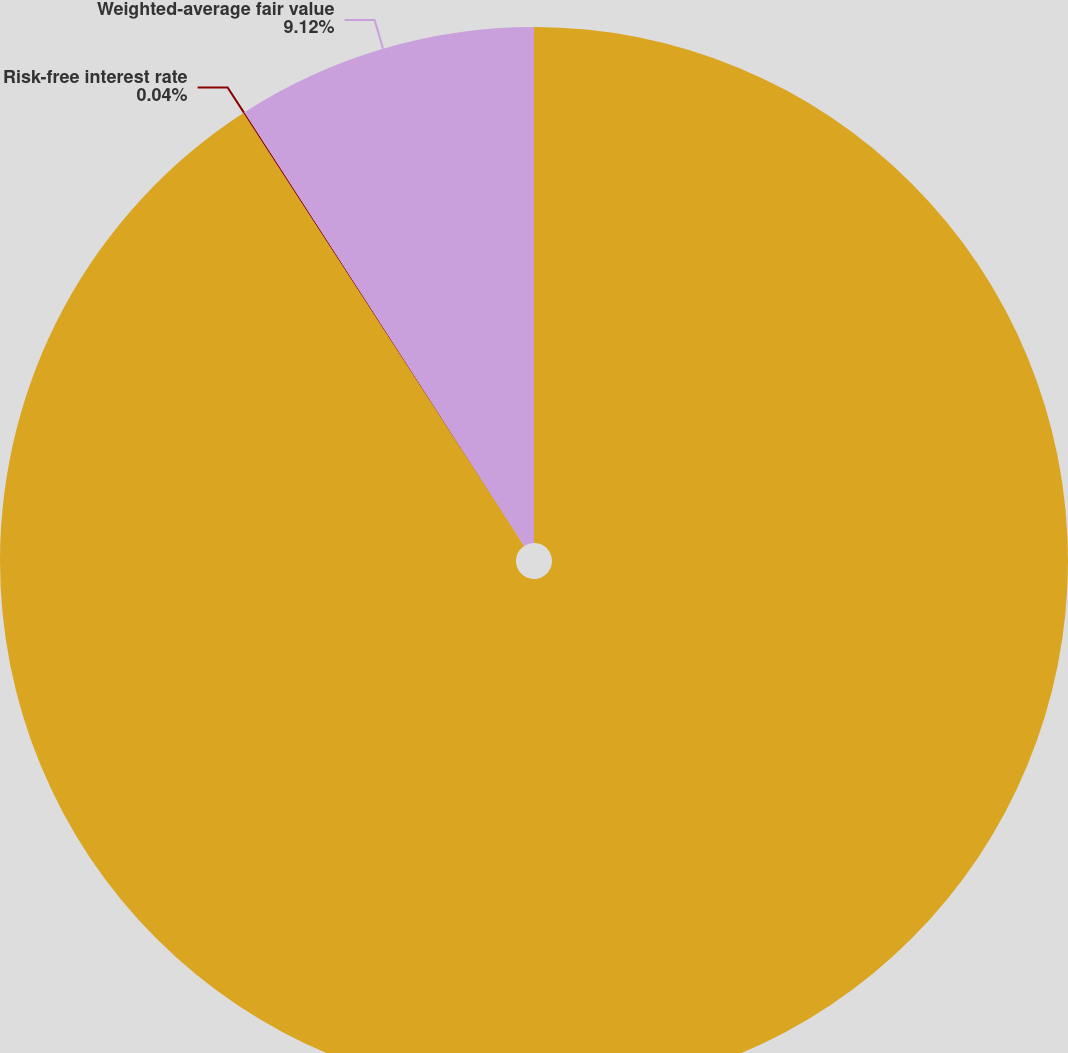Convert chart to OTSL. <chart><loc_0><loc_0><loc_500><loc_500><pie_chart><fcel>Year ended April 30<fcel>Risk-free interest rate<fcel>Weighted-average fair value<nl><fcel>90.84%<fcel>0.04%<fcel>9.12%<nl></chart> 